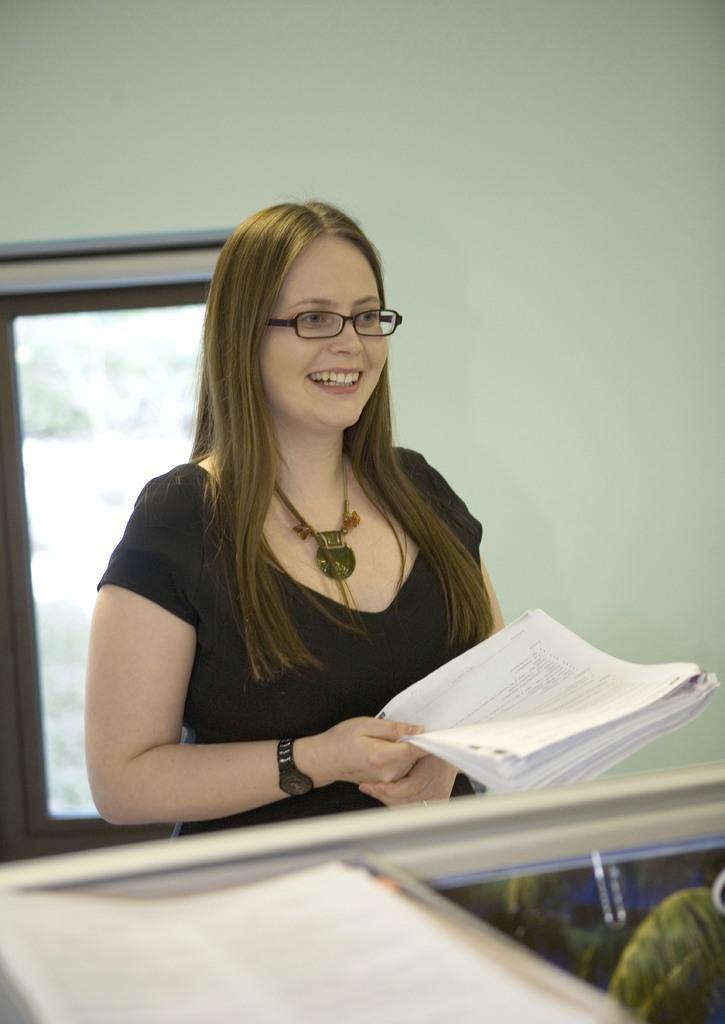Could you give a brief overview of what you see in this image? In the center of the image there is a lady holding papers in her hand. At the background of the image there is a wall and window. At the bottom of the image there are some objects. 